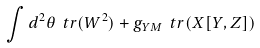<formula> <loc_0><loc_0><loc_500><loc_500>\int d ^ { 2 } \theta \ t r ( W ^ { 2 } ) + g _ { Y M } \ t r ( X [ Y , Z ] )</formula> 